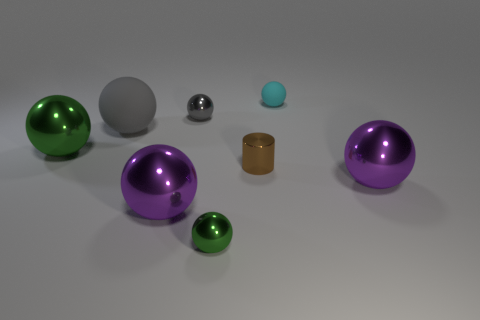Subtract all small spheres. How many spheres are left? 4 Subtract all purple spheres. How many spheres are left? 5 Add 1 tiny gray rubber cylinders. How many objects exist? 9 Subtract all purple spheres. Subtract all red cylinders. How many spheres are left? 5 Subtract all cylinders. How many objects are left? 7 Subtract 0 red blocks. How many objects are left? 8 Subtract all big gray metallic things. Subtract all small gray shiny objects. How many objects are left? 7 Add 6 big gray rubber spheres. How many big gray rubber spheres are left? 7 Add 8 tiny gray objects. How many tiny gray objects exist? 9 